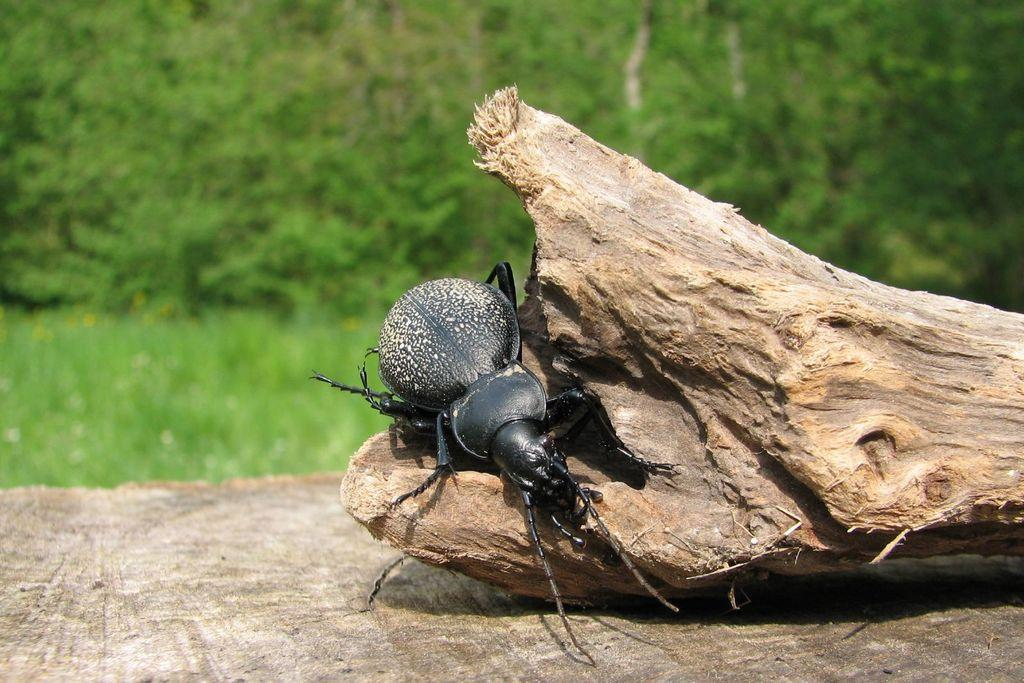What is on the wooden log in the image? There is an insect on the wooden log in the image. How is the wooden log positioned in the image? The wooden log is on a platform in the image. What can be seen in the background of the image? There are plants and trees in the background of the image. What type of leather is visible on the donkey in the image? There is no donkey or leather present in the image; it features an insect on a wooden log on a platform with plants and trees in the background. 